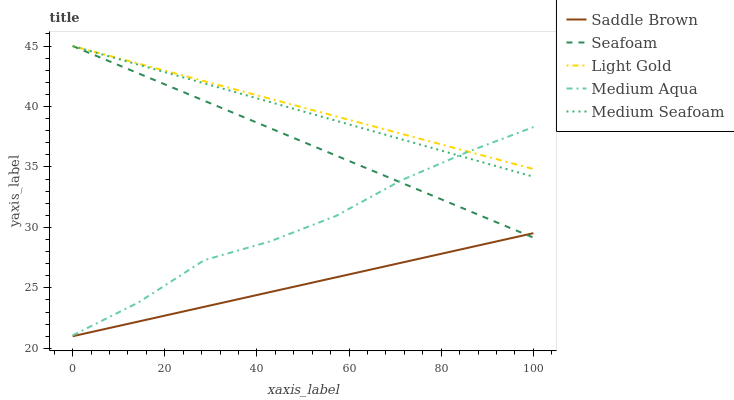Does Saddle Brown have the minimum area under the curve?
Answer yes or no. Yes. Does Light Gold have the maximum area under the curve?
Answer yes or no. Yes. Does Medium Seafoam have the minimum area under the curve?
Answer yes or no. No. Does Medium Seafoam have the maximum area under the curve?
Answer yes or no. No. Is Medium Seafoam the smoothest?
Answer yes or no. Yes. Is Medium Aqua the roughest?
Answer yes or no. Yes. Is Light Gold the smoothest?
Answer yes or no. No. Is Light Gold the roughest?
Answer yes or no. No. Does Saddle Brown have the lowest value?
Answer yes or no. Yes. Does Medium Seafoam have the lowest value?
Answer yes or no. No. Does Seafoam have the highest value?
Answer yes or no. Yes. Does Saddle Brown have the highest value?
Answer yes or no. No. Is Saddle Brown less than Light Gold?
Answer yes or no. Yes. Is Medium Aqua greater than Saddle Brown?
Answer yes or no. Yes. Does Seafoam intersect Light Gold?
Answer yes or no. Yes. Is Seafoam less than Light Gold?
Answer yes or no. No. Is Seafoam greater than Light Gold?
Answer yes or no. No. Does Saddle Brown intersect Light Gold?
Answer yes or no. No. 